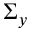<formula> <loc_0><loc_0><loc_500><loc_500>\Sigma _ { y }</formula> 